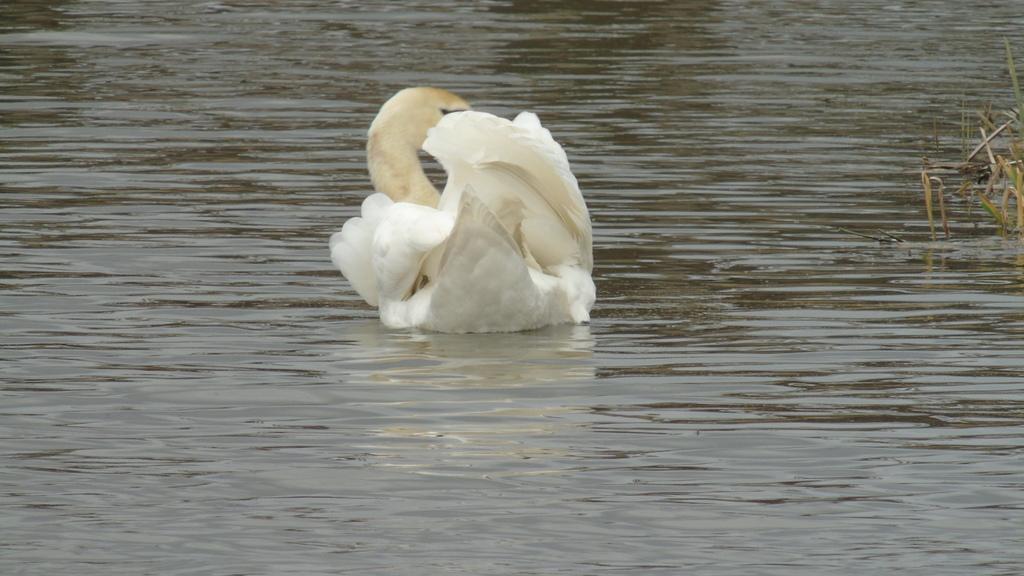Can you describe this image briefly? A white swan is swimming on the water and there are plants on the right. 